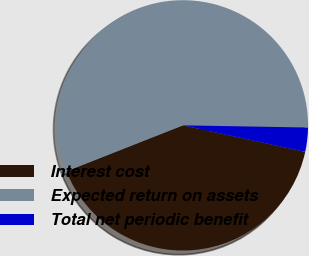Convert chart. <chart><loc_0><loc_0><loc_500><loc_500><pie_chart><fcel>Interest cost<fcel>Expected return on assets<fcel>Total net periodic benefit<nl><fcel>40.62%<fcel>56.25%<fcel>3.12%<nl></chart> 